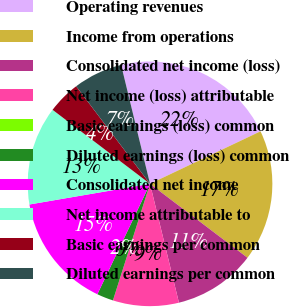Convert chart to OTSL. <chart><loc_0><loc_0><loc_500><loc_500><pie_chart><fcel>Operating revenues<fcel>Income from operations<fcel>Consolidated net income (loss)<fcel>Net income (loss) attributable<fcel>Basic earnings (loss) common<fcel>Diluted earnings (loss) common<fcel>Consolidated net income<fcel>Net income attributable to<fcel>Basic earnings per common<fcel>Diluted earnings per common<nl><fcel>21.74%<fcel>17.39%<fcel>10.87%<fcel>8.7%<fcel>0.0%<fcel>2.18%<fcel>15.22%<fcel>13.04%<fcel>4.35%<fcel>6.52%<nl></chart> 